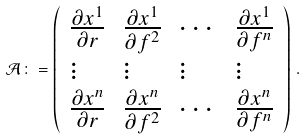<formula> <loc_0><loc_0><loc_500><loc_500>\mathcal { A } \colon = \left ( \begin{array} { l l l l } \frac { \partial x ^ { 1 } } { \partial r } & \frac { \partial x ^ { 1 } } { \partial f ^ { 2 } } & \cdots & \frac { \partial x ^ { 1 } } { \partial f ^ { n } } \\ \vdots & \vdots & \vdots & \vdots \\ \frac { \partial x ^ { n } } { \partial r } & \frac { \partial x ^ { n } } { \partial f ^ { 2 } } & \cdots & \frac { \partial x ^ { n } } { \partial f ^ { n } } \end{array} \right ) \, .</formula> 